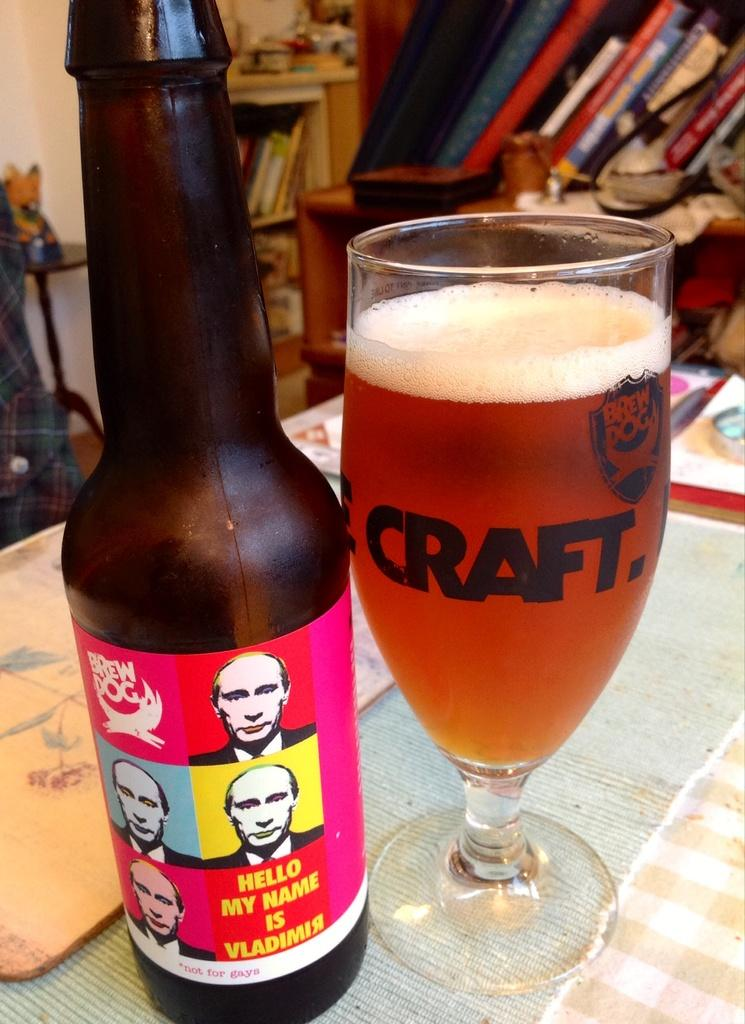<image>
Describe the image concisely. Beer that has Vladimir Putin all over with a pop art label and craft beer glass beside it. 